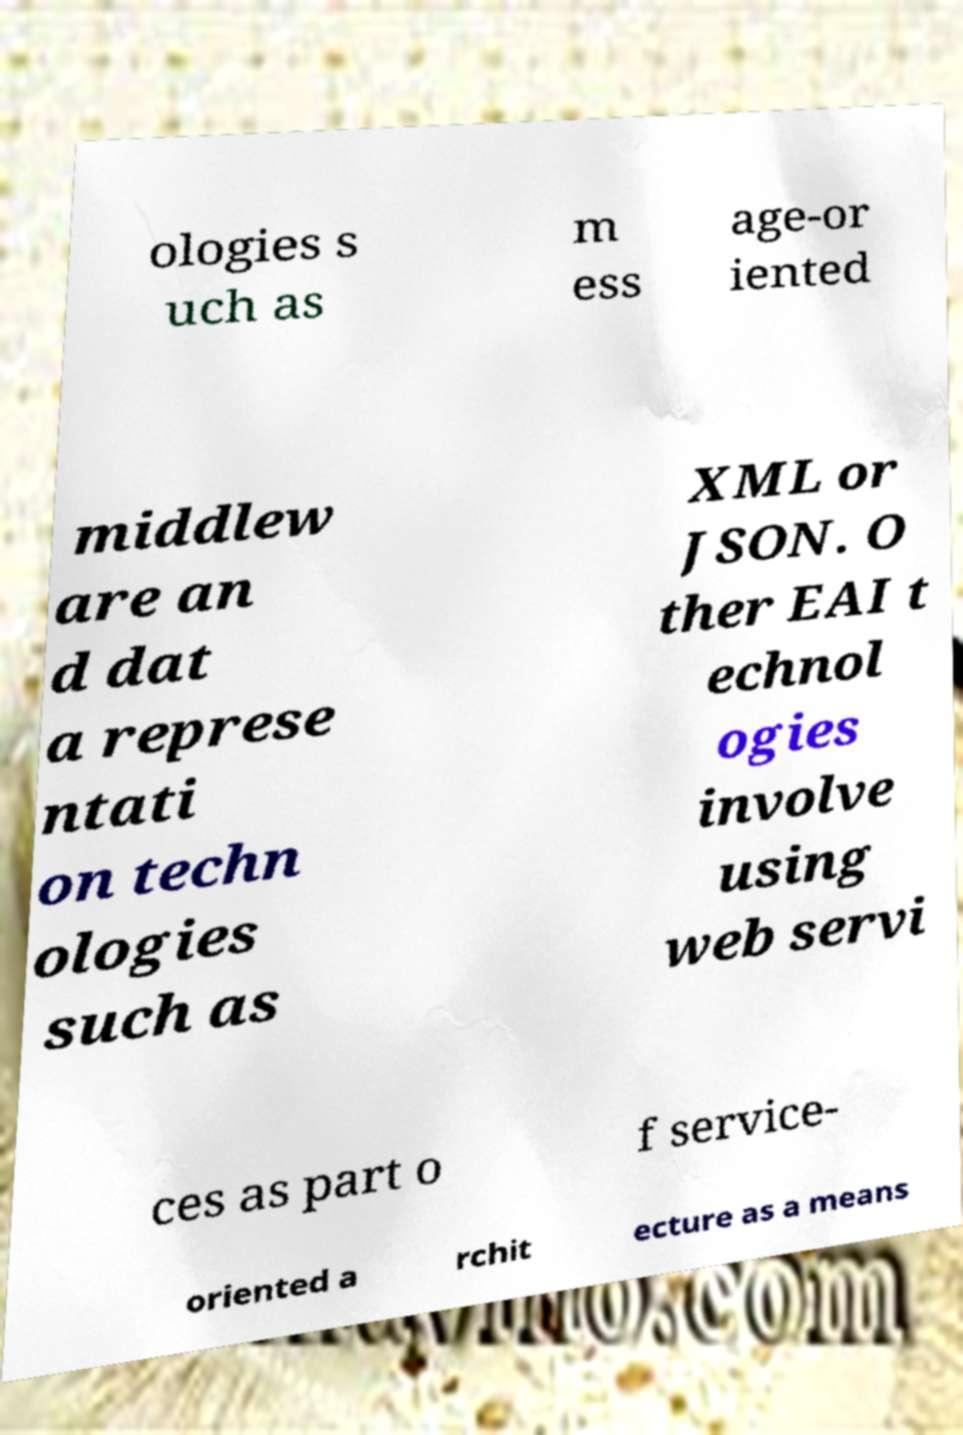Please identify and transcribe the text found in this image. ologies s uch as m ess age-or iented middlew are an d dat a represe ntati on techn ologies such as XML or JSON. O ther EAI t echnol ogies involve using web servi ces as part o f service- oriented a rchit ecture as a means 